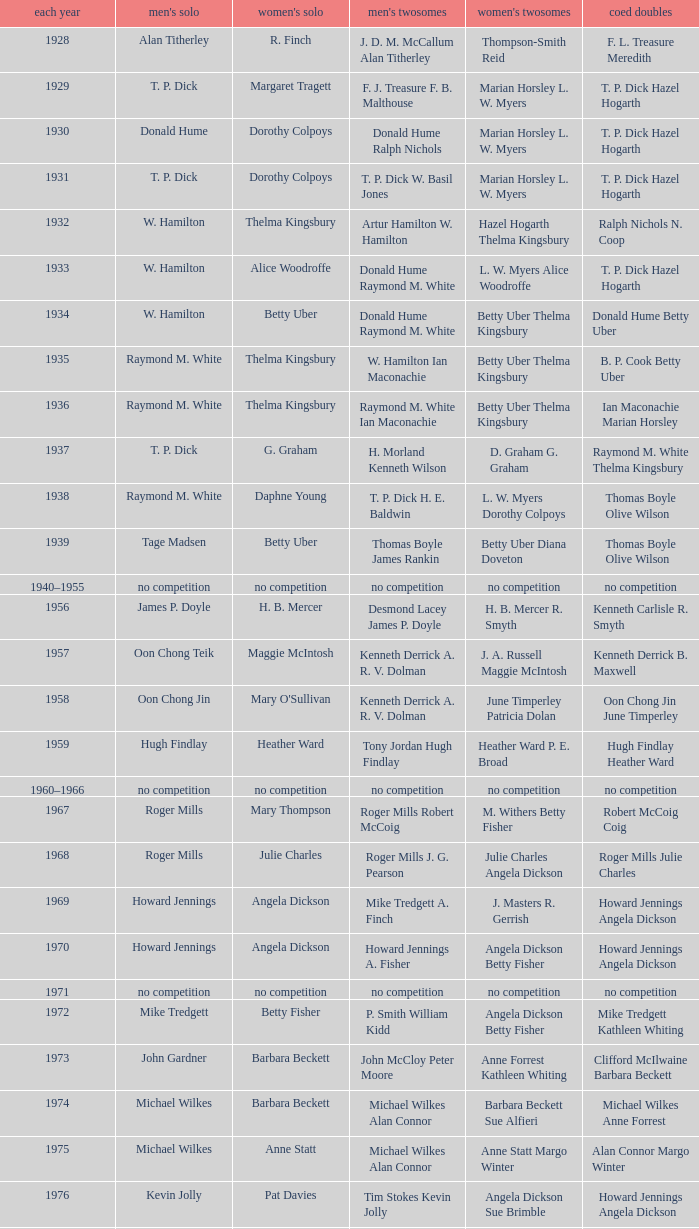Who won the Men's singles in the year that Ian Maconachie Marian Horsley won the Mixed doubles? Raymond M. White. 